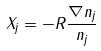<formula> <loc_0><loc_0><loc_500><loc_500>X _ { j } = - R \frac { \nabla n _ { j } } { n _ { j } }</formula> 